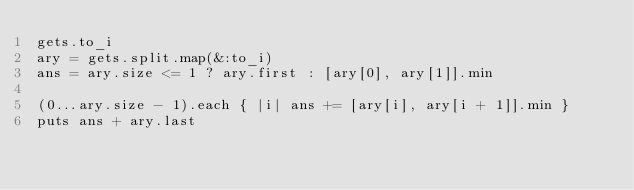<code> <loc_0><loc_0><loc_500><loc_500><_Ruby_>gets.to_i
ary = gets.split.map(&:to_i)
ans = ary.size <= 1 ? ary.first : [ary[0], ary[1]].min

(0...ary.size - 1).each { |i| ans += [ary[i], ary[i + 1]].min }
puts ans + ary.last
</code> 